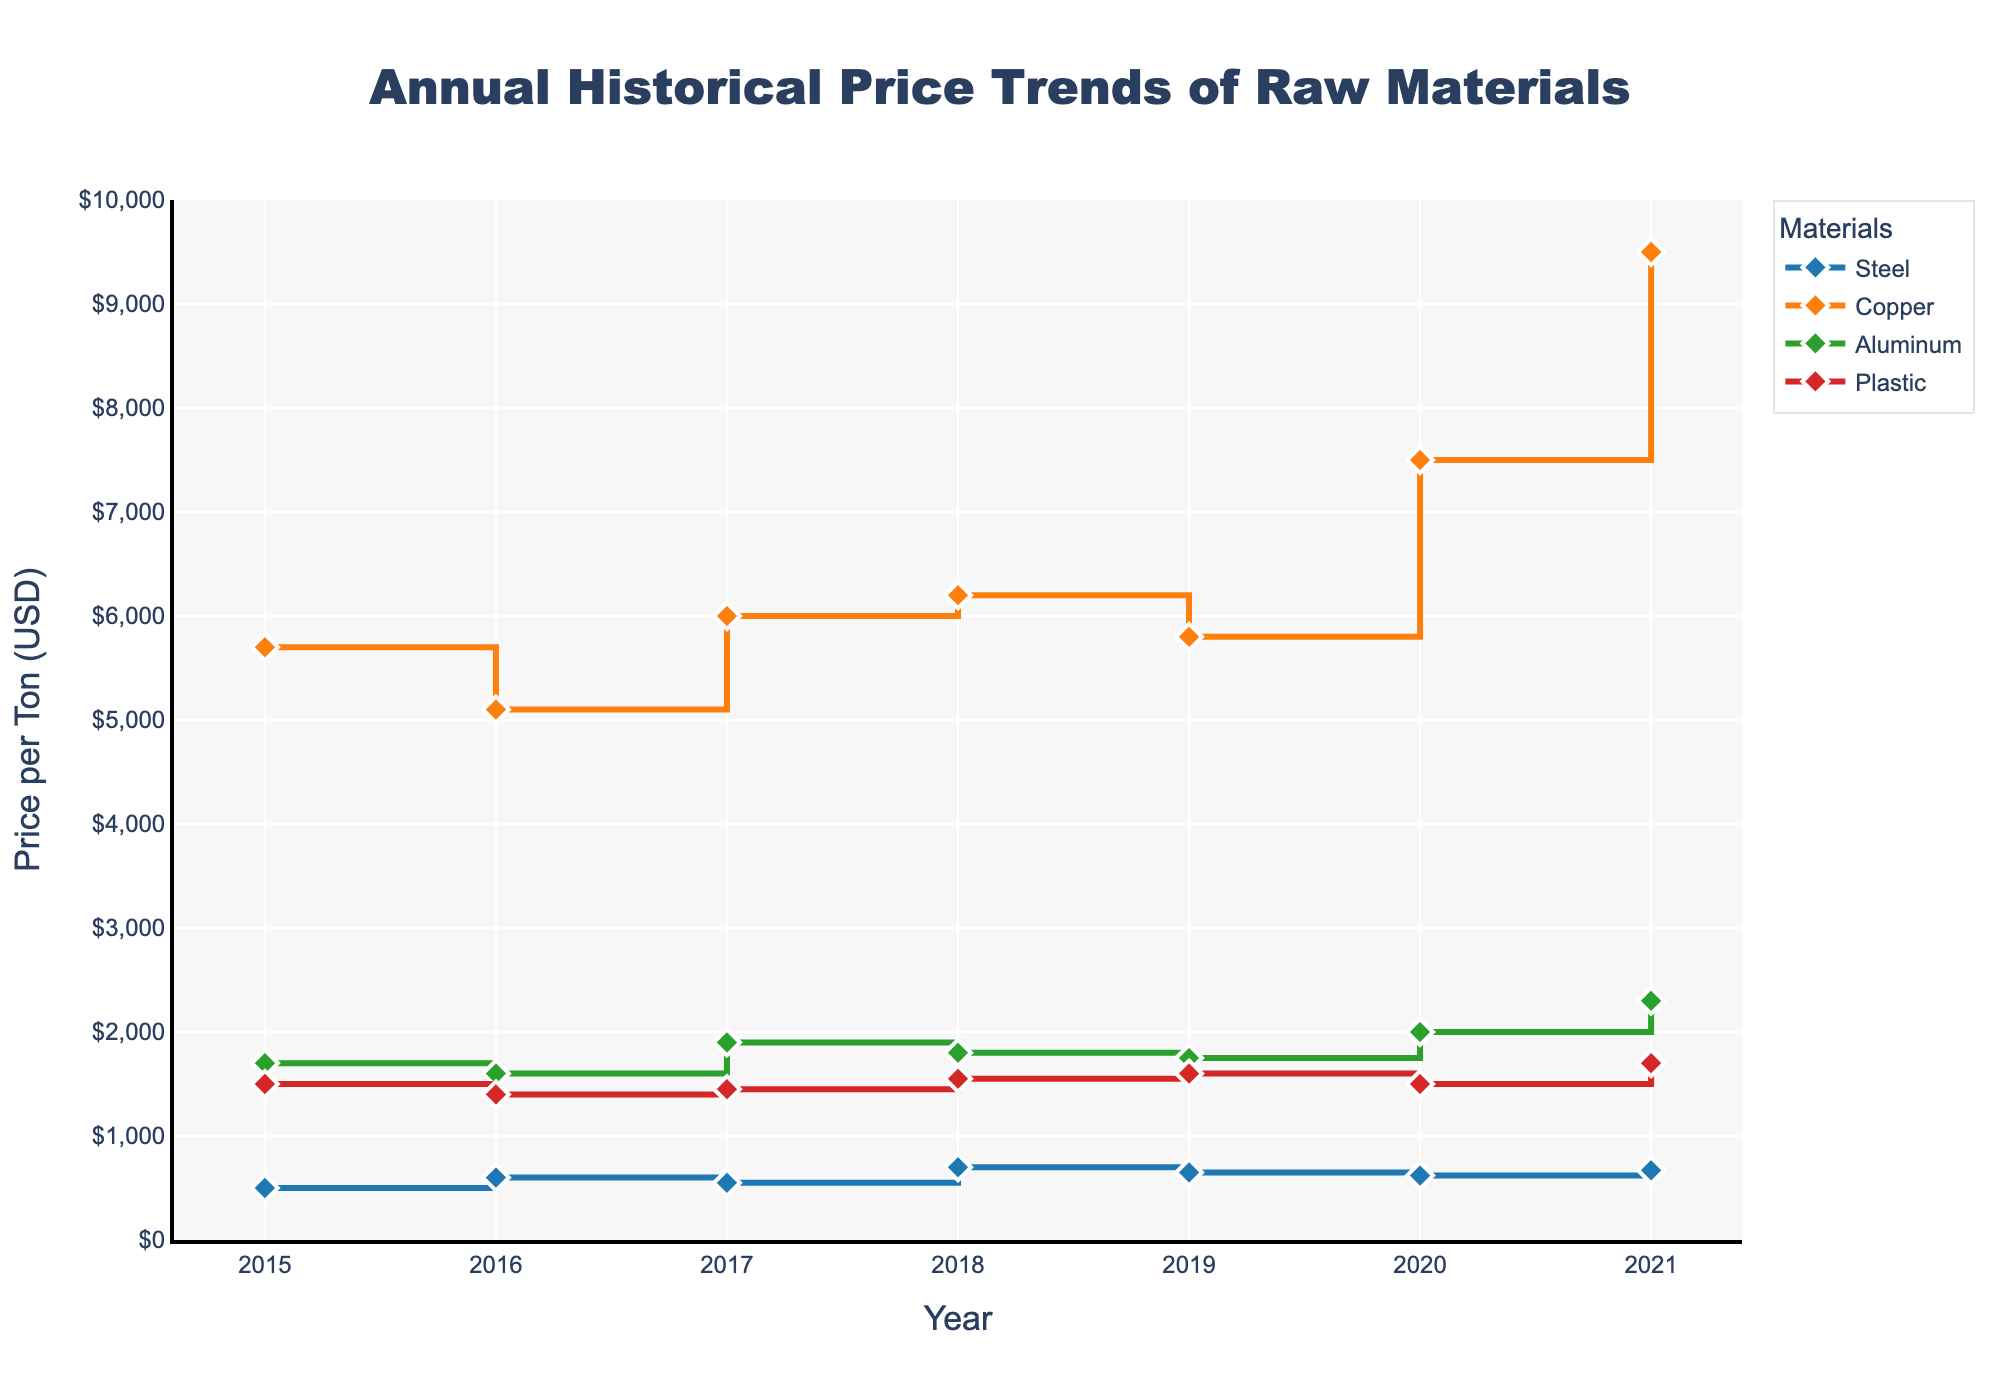What's the title of the figure? Look at the text at the very top of the figure. It states "Annual Historical Price Trends of Raw Materials".
Answer: Annual Historical Price Trends of Raw Materials How many materials are tracked in the figure? Check the legend on the right side, which lists all tracked materials. There are four listed: Steel, Copper, Aluminum, and Plastic.
Answer: Four Which material had the highest price per ton in 2021? Locate the year 2021 on the x-axis and look for the highest point among the four lines. Copper reaches the highest point.
Answer: Copper What was the price of Aluminum per ton in 2017? Follow the Aluminum line until it intersects with the year 2017 on the x-axis. The price point is marked on the y-axis.
Answer: 1900 Between which years did Steel prices decrease? Observe the trend of the Steel line and identify the years where the line drops from one year to the next. Steel prices drop between 2017-2018 and 2019-2020.
Answer: 2017-2018 and 2019-2020 Which material showed the most significant increase in price from 2020 to 2021? For each material, compare the difference in y-values from 2020 to 2021. Copper shows the largest jump.
Answer: Copper What is the price difference between Plastic in 2016 and 2021? Look at the Plastic line and note the y-values for 2016 and 2021. Subtract the 2016 value from the 2021 value (1700 - 1400 = 300).
Answer: 300 In which year did Steel have the highest price? Follow the Steel line to find the highest point and then check its year on the x-axis. The peak price occurs in 2018.
Answer: 2018 Which material had the most stable price trend over the years? Look at each material line's fluctuation over the years. The Plastic line appears to have the smallest overall fluctuations.
Answer: Plastic What was the overall trend for Copper prices from 2015 to 2021? Observe the Copper line from the beginning to the end. It generally trends upwards, despite fluctuations.
Answer: Upward trend 